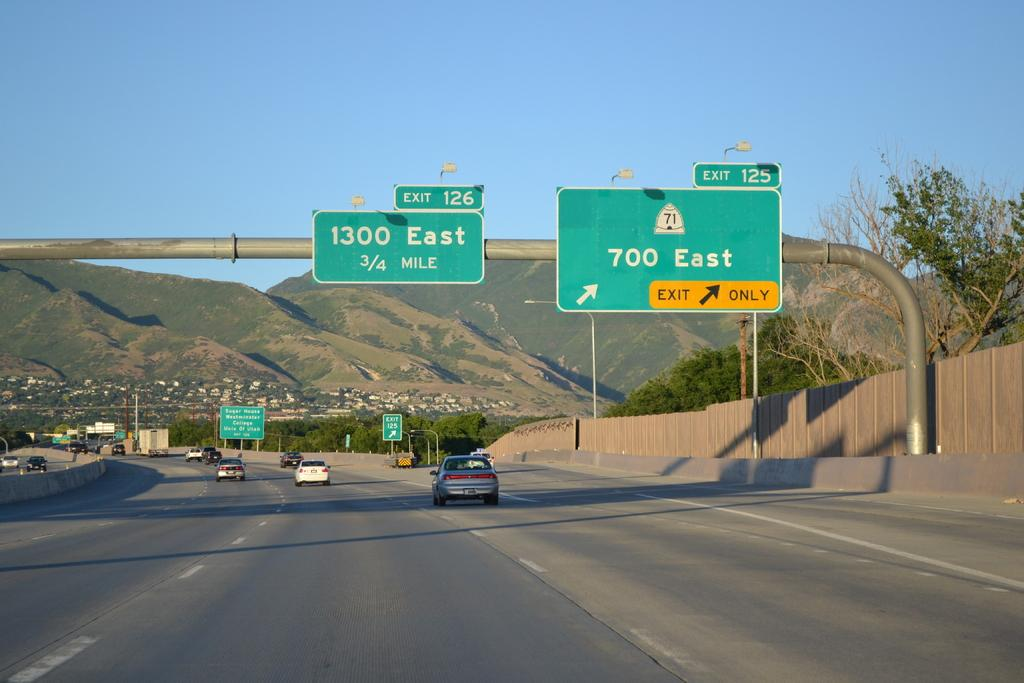Provide a one-sentence caption for the provided image. Green road sign that shows 1300 east and 700 east. 